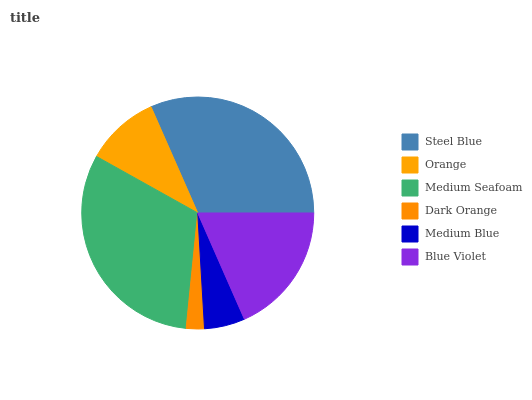Is Dark Orange the minimum?
Answer yes or no. Yes. Is Steel Blue the maximum?
Answer yes or no. Yes. Is Orange the minimum?
Answer yes or no. No. Is Orange the maximum?
Answer yes or no. No. Is Steel Blue greater than Orange?
Answer yes or no. Yes. Is Orange less than Steel Blue?
Answer yes or no. Yes. Is Orange greater than Steel Blue?
Answer yes or no. No. Is Steel Blue less than Orange?
Answer yes or no. No. Is Blue Violet the high median?
Answer yes or no. Yes. Is Orange the low median?
Answer yes or no. Yes. Is Orange the high median?
Answer yes or no. No. Is Dark Orange the low median?
Answer yes or no. No. 